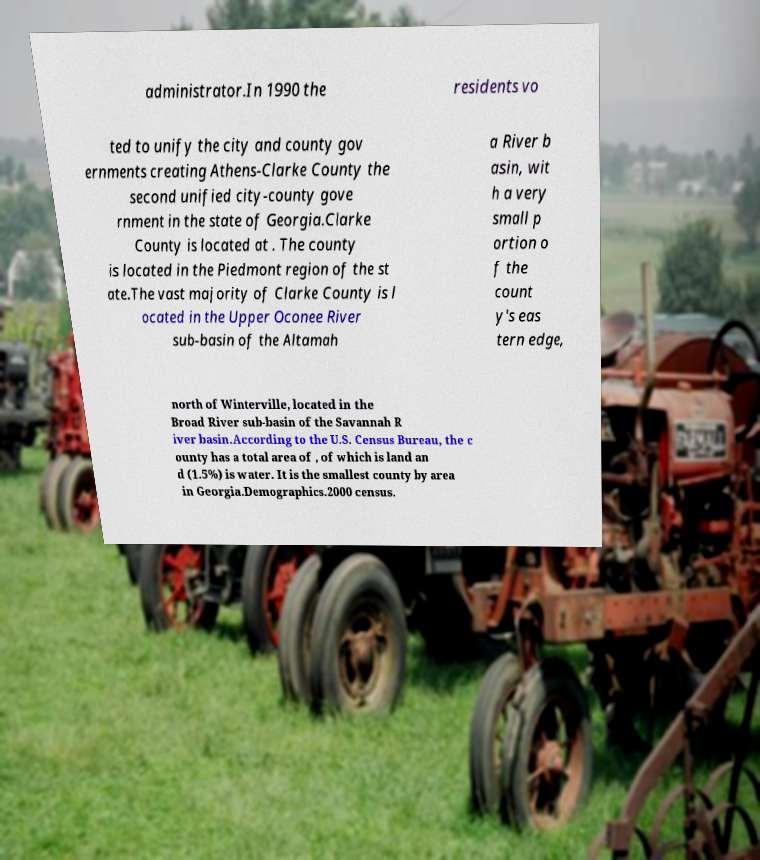Please identify and transcribe the text found in this image. administrator.In 1990 the residents vo ted to unify the city and county gov ernments creating Athens-Clarke County the second unified city-county gove rnment in the state of Georgia.Clarke County is located at . The county is located in the Piedmont region of the st ate.The vast majority of Clarke County is l ocated in the Upper Oconee River sub-basin of the Altamah a River b asin, wit h a very small p ortion o f the count y's eas tern edge, north of Winterville, located in the Broad River sub-basin of the Savannah R iver basin.According to the U.S. Census Bureau, the c ounty has a total area of , of which is land an d (1.5%) is water. It is the smallest county by area in Georgia.Demographics.2000 census. 